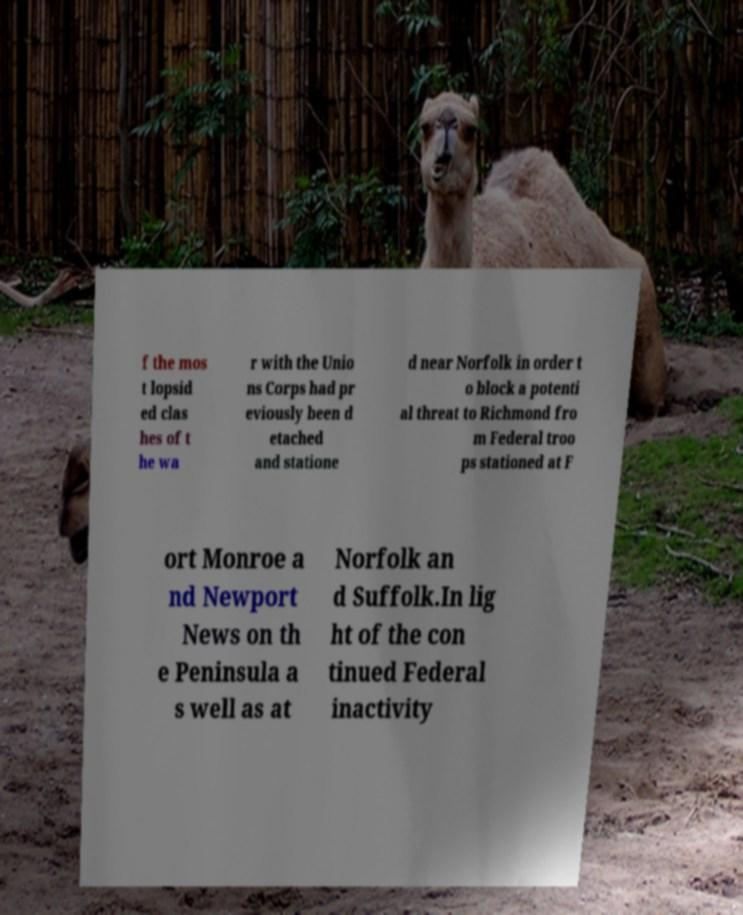I need the written content from this picture converted into text. Can you do that? f the mos t lopsid ed clas hes of t he wa r with the Unio ns Corps had pr eviously been d etached and statione d near Norfolk in order t o block a potenti al threat to Richmond fro m Federal troo ps stationed at F ort Monroe a nd Newport News on th e Peninsula a s well as at Norfolk an d Suffolk.In lig ht of the con tinued Federal inactivity 